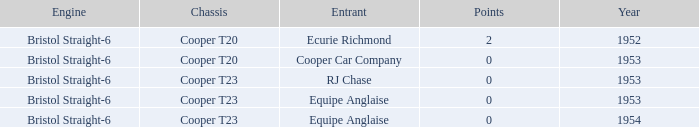Which of the biggest points numbers had a year more recent than 1953? 0.0. 